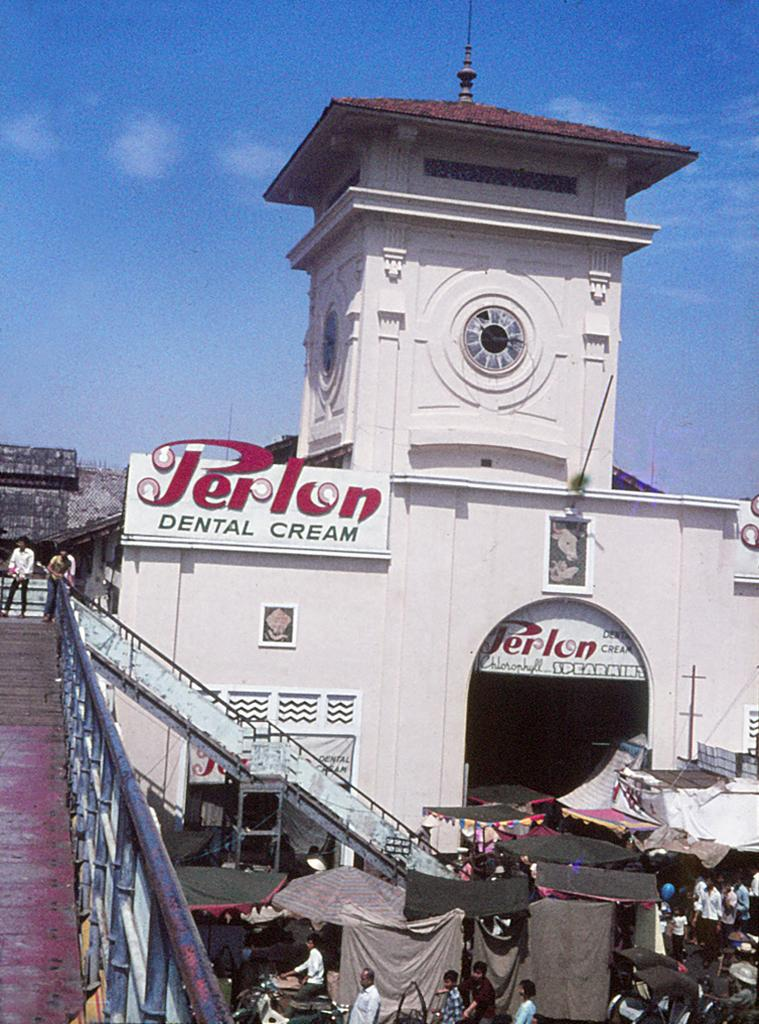How many people are in the image? There is a group of people in the image. What type of temporary shelters can be seen in the image? There are tents in the image. What kind of signage is present in the image? There are posters in the image. What type of structure is visible in the image? There is a building in the image. What architectural feature is present in the image with two people standing on it? There is a bridge with two people standing on it in the image. What other objects can be seen in the image? There are some objects in the image. What can be seen in the background of the image? The sky is visible in the background of the image. What type of tool is being used by the sisters to swim in the image? There are no sisters or swimming activity present in the image, and therefore no such tool can be observed. What type of wrench is visible in the image? There is no wrench present in the image. 